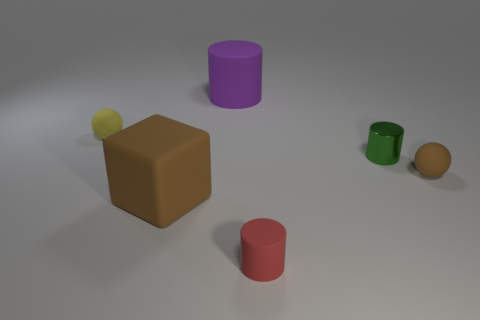Subtract all green cylinders. How many cylinders are left? 2 Add 2 small yellow objects. How many objects exist? 8 Subtract all brown spheres. How many spheres are left? 1 Subtract 0 purple cubes. How many objects are left? 6 Subtract all cubes. How many objects are left? 5 Subtract 1 cubes. How many cubes are left? 0 Subtract all purple spheres. Subtract all gray cylinders. How many spheres are left? 2 Subtract all yellow cylinders. How many purple blocks are left? 0 Subtract all green things. Subtract all brown rubber objects. How many objects are left? 3 Add 4 red matte cylinders. How many red matte cylinders are left? 5 